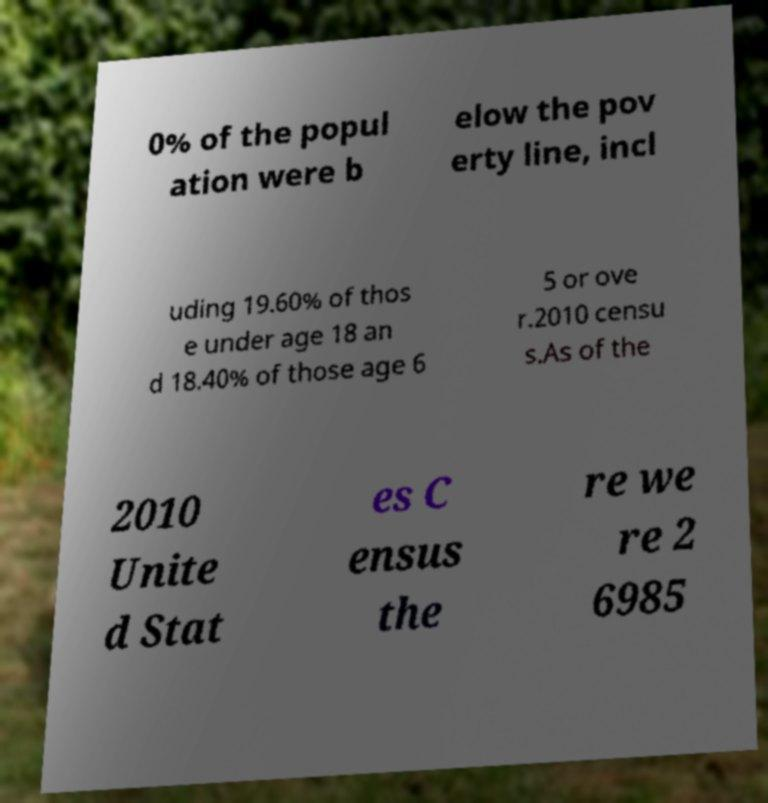Please identify and transcribe the text found in this image. 0% of the popul ation were b elow the pov erty line, incl uding 19.60% of thos e under age 18 an d 18.40% of those age 6 5 or ove r.2010 censu s.As of the 2010 Unite d Stat es C ensus the re we re 2 6985 